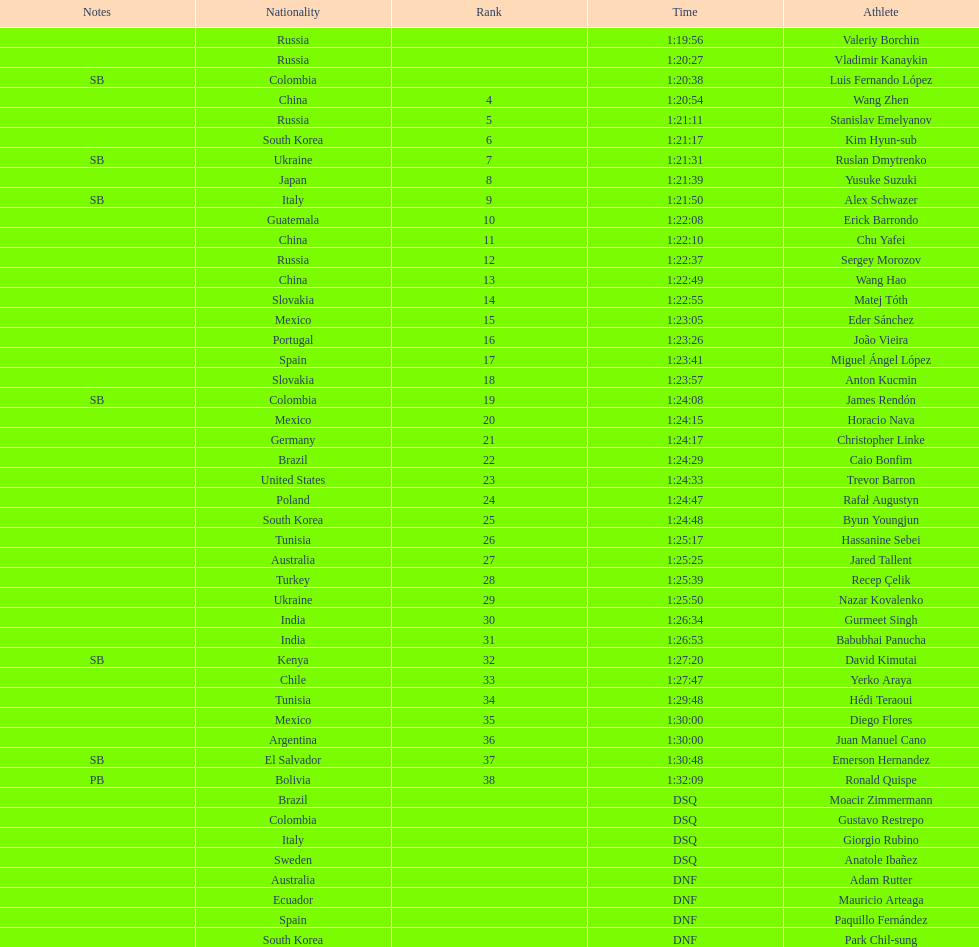Who placed in the top spot? Valeriy Borchin. 